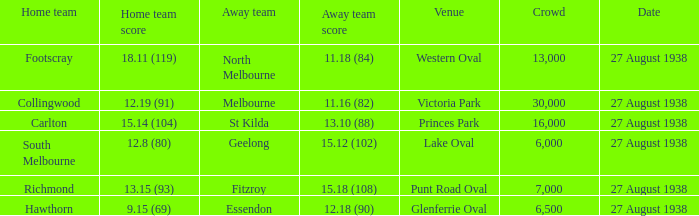15 (93)? 7000.0. 